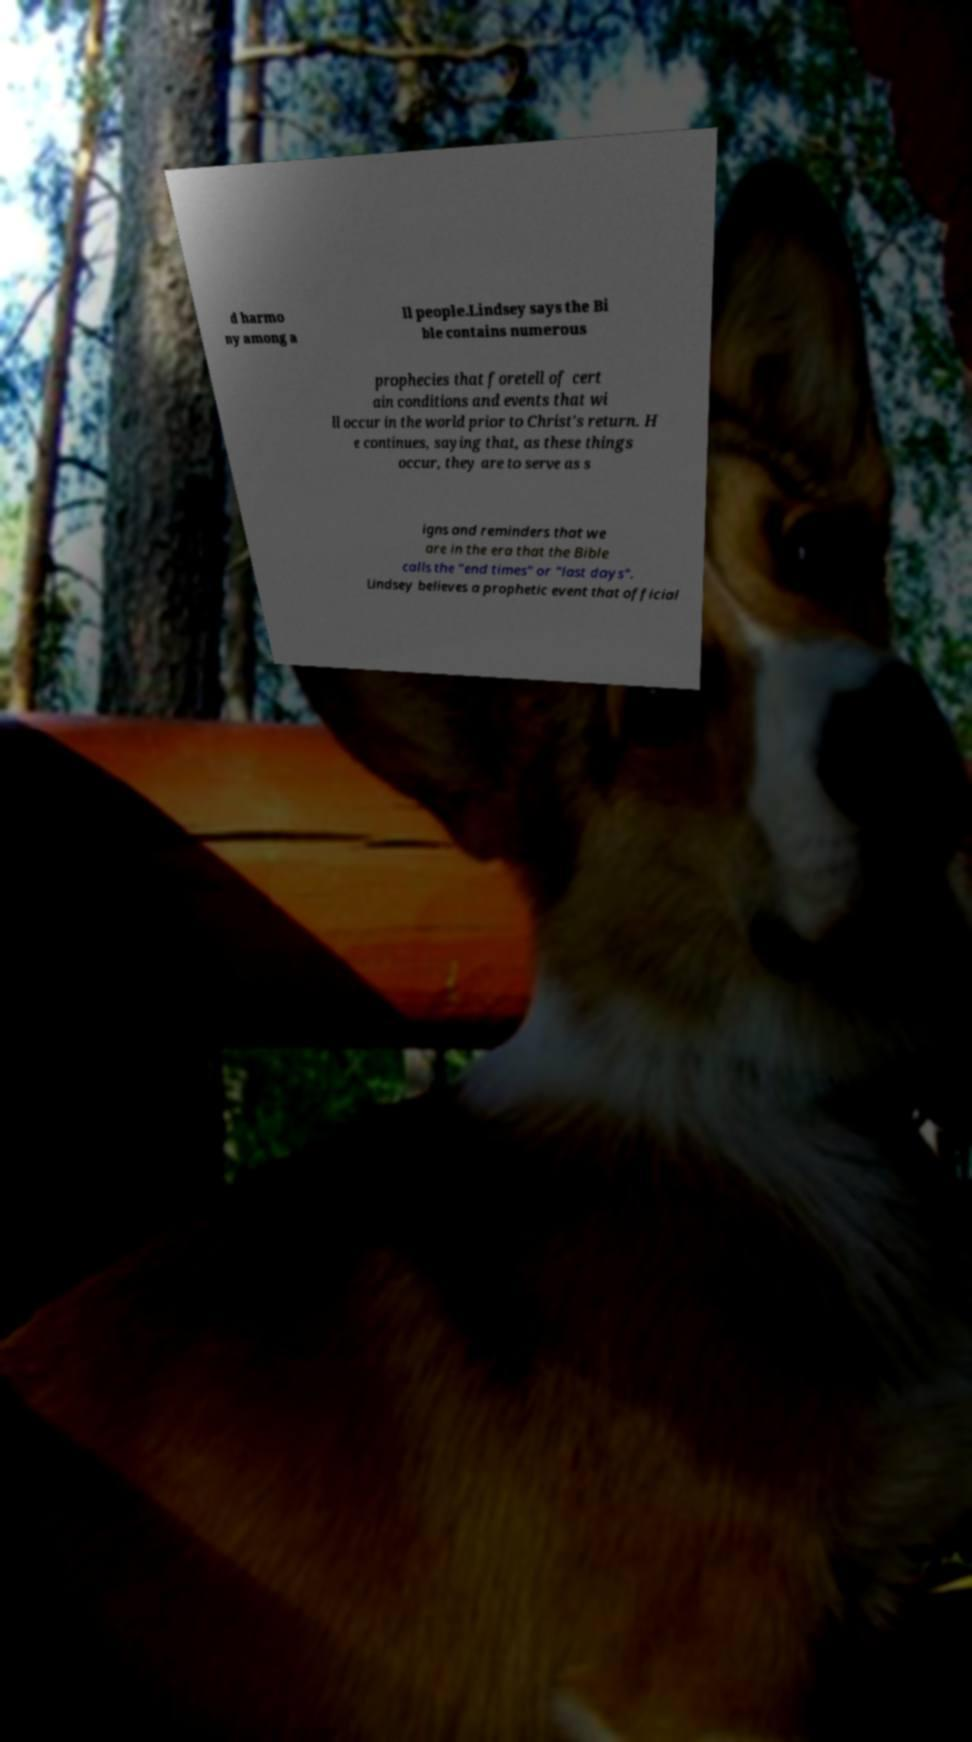Could you assist in decoding the text presented in this image and type it out clearly? d harmo ny among a ll people.Lindsey says the Bi ble contains numerous prophecies that foretell of cert ain conditions and events that wi ll occur in the world prior to Christ's return. H e continues, saying that, as these things occur, they are to serve as s igns and reminders that we are in the era that the Bible calls the "end times" or "last days". Lindsey believes a prophetic event that official 